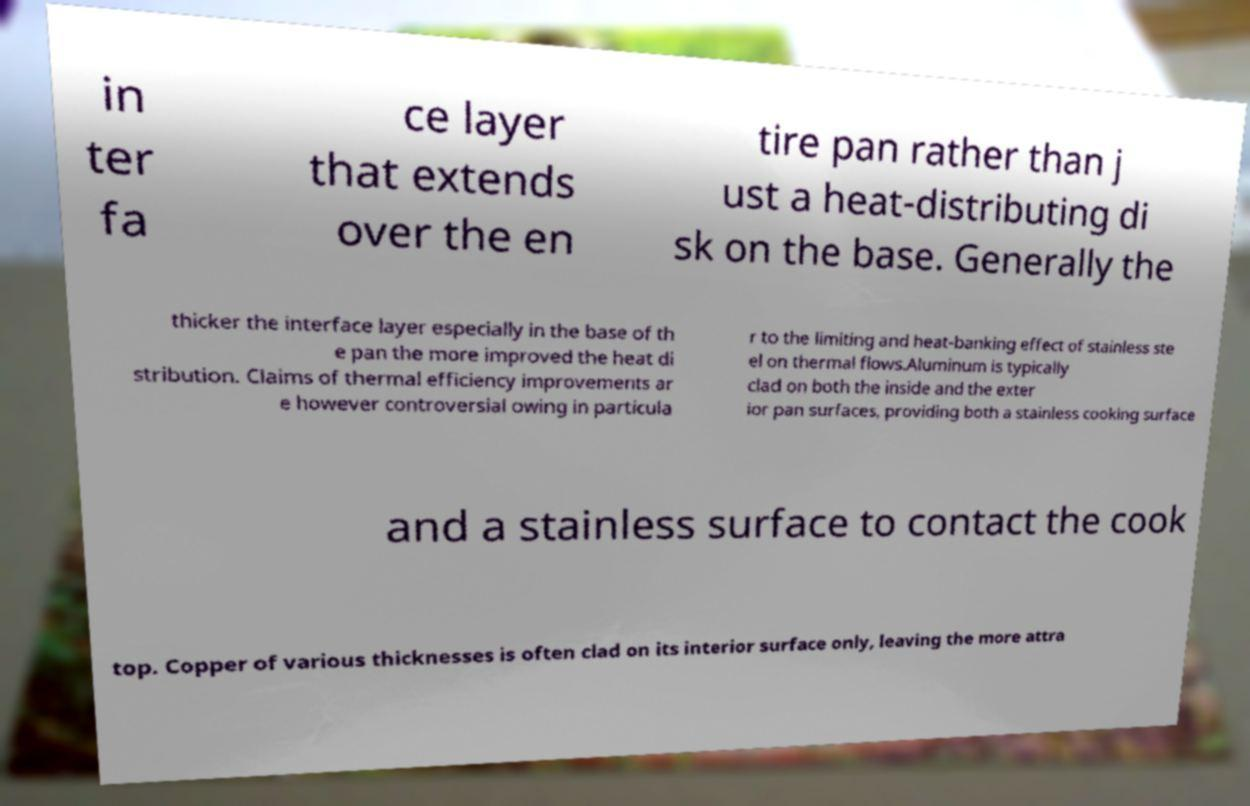There's text embedded in this image that I need extracted. Can you transcribe it verbatim? in ter fa ce layer that extends over the en tire pan rather than j ust a heat-distributing di sk on the base. Generally the thicker the interface layer especially in the base of th e pan the more improved the heat di stribution. Claims of thermal efficiency improvements ar e however controversial owing in particula r to the limiting and heat-banking effect of stainless ste el on thermal flows.Aluminum is typically clad on both the inside and the exter ior pan surfaces, providing both a stainless cooking surface and a stainless surface to contact the cook top. Copper of various thicknesses is often clad on its interior surface only, leaving the more attra 